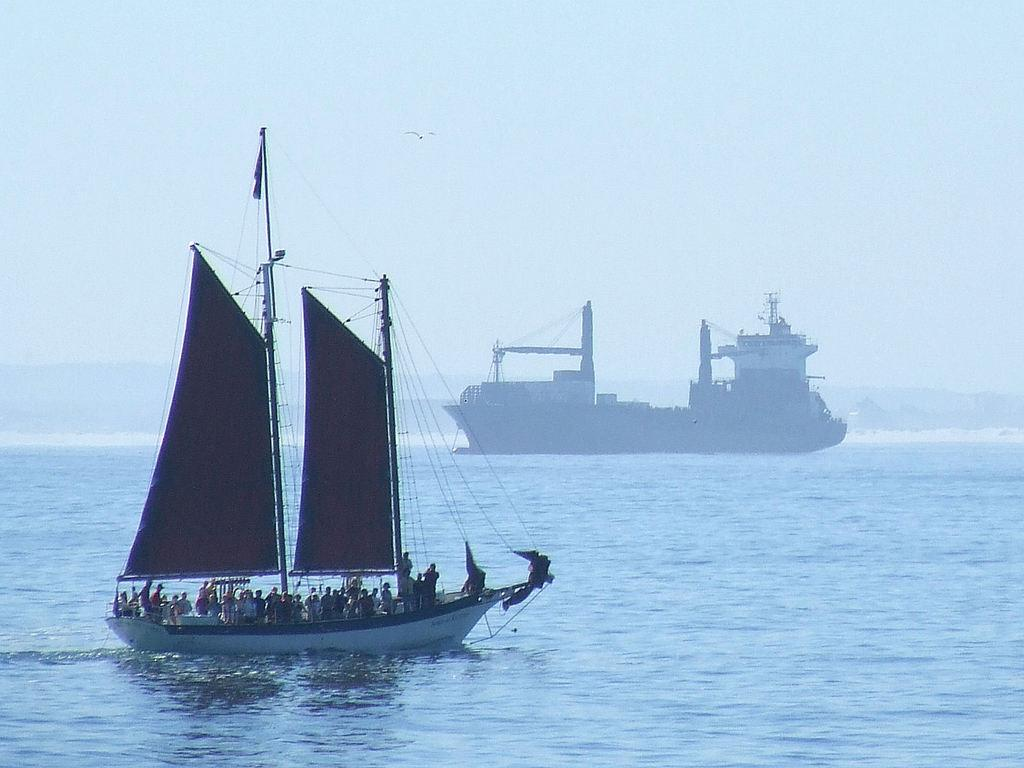What is the main subject of the image? The main subject of the image is a boat. Where is the boat located? The boat is on the water. Are there any people in the boat? Yes, there are people in the boat. What can be seen in the background of the image? The sky is visible in the background of the image. What is the color of the sky? The color of the sky is blue. What is the price of the linen used to make the boat in the image? There is no information about the boat being made of linen, nor is there any mention of a price in the image or the provided facts. 